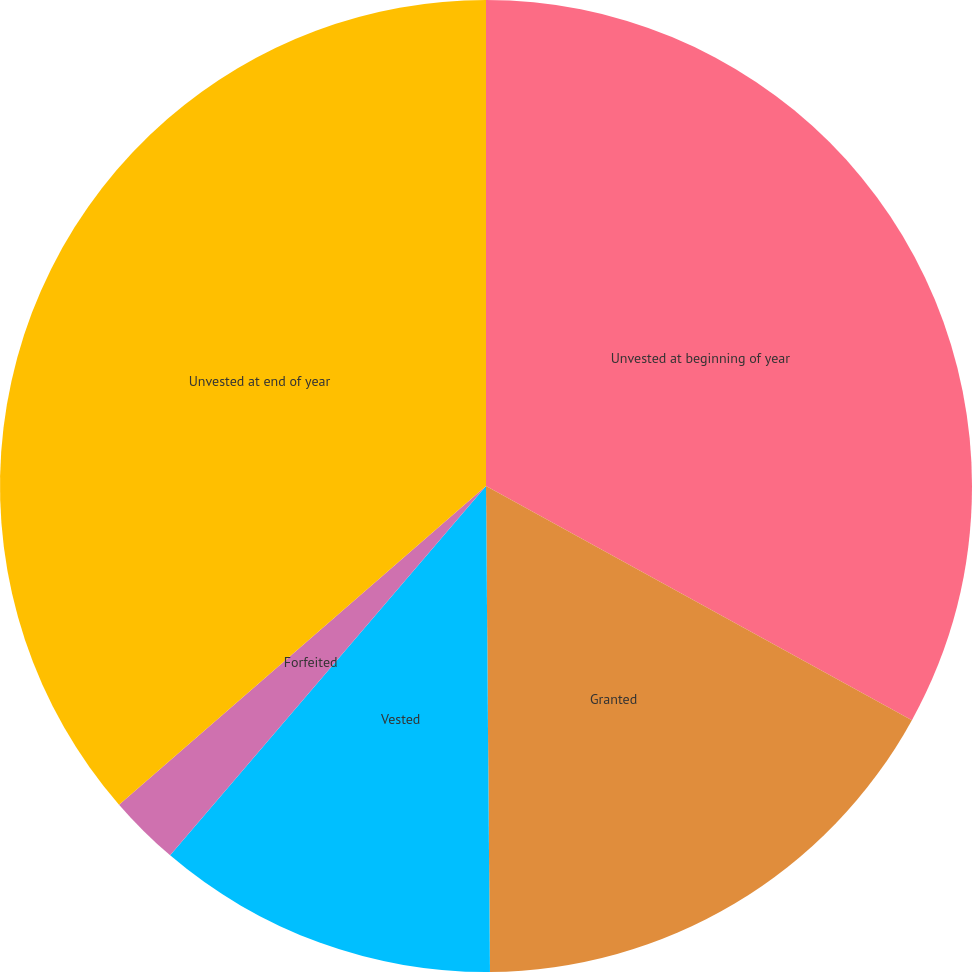<chart> <loc_0><loc_0><loc_500><loc_500><pie_chart><fcel>Unvested at beginning of year<fcel>Granted<fcel>Vested<fcel>Forfeited<fcel>Unvested at end of year<nl><fcel>33.0%<fcel>16.87%<fcel>11.39%<fcel>2.36%<fcel>36.38%<nl></chart> 